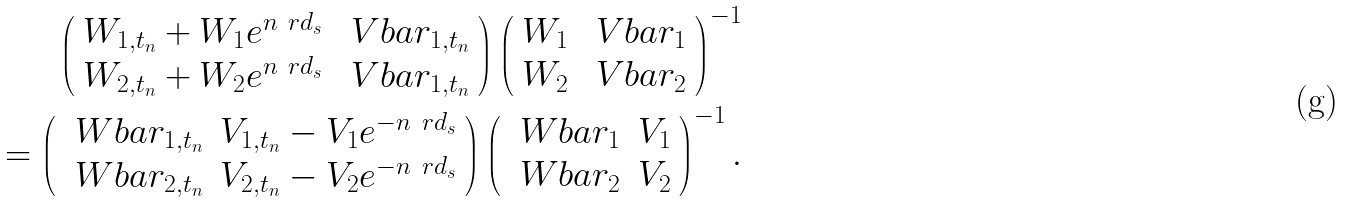<formula> <loc_0><loc_0><loc_500><loc_500>\left ( \begin{array} { c c } W _ { 1 , t _ { n } } + W _ { 1 } e ^ { n \ r d _ { s } } & \ V b a r _ { 1 , t _ { n } } \\ W _ { 2 , t _ { n } } + W _ { 2 } e ^ { n \ r d _ { s } } & \ V b a r _ { 1 , t _ { n } } \end{array} \right ) \left ( \begin{array} { c c } W _ { 1 } & \ V b a r _ { 1 } \\ W _ { 2 } & \ V b a r _ { 2 } \end{array} \right ) ^ { - 1 } \\ = \left ( \begin{array} { c c } \ W b a r _ { 1 , t _ { n } } & V _ { 1 , t _ { n } } - V _ { 1 } e ^ { - n \ r d _ { s } } \\ \ W b a r _ { 2 , t _ { n } } & V _ { 2 , t _ { n } } - V _ { 2 } e ^ { - n \ r d _ { s } } \end{array} \right ) \left ( \begin{array} { c c } \ W b a r _ { 1 } & V _ { 1 } \\ \ W b a r _ { 2 } & V _ { 2 } \end{array} \right ) ^ { - 1 } .</formula> 